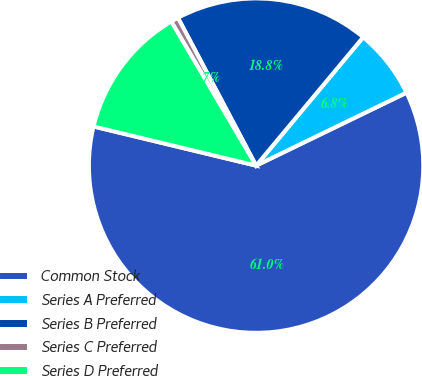<chart> <loc_0><loc_0><loc_500><loc_500><pie_chart><fcel>Common Stock<fcel>Series A Preferred<fcel>Series B Preferred<fcel>Series C Preferred<fcel>Series D Preferred<nl><fcel>60.95%<fcel>6.75%<fcel>18.8%<fcel>0.73%<fcel>12.77%<nl></chart> 